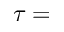<formula> <loc_0><loc_0><loc_500><loc_500>\tau =</formula> 